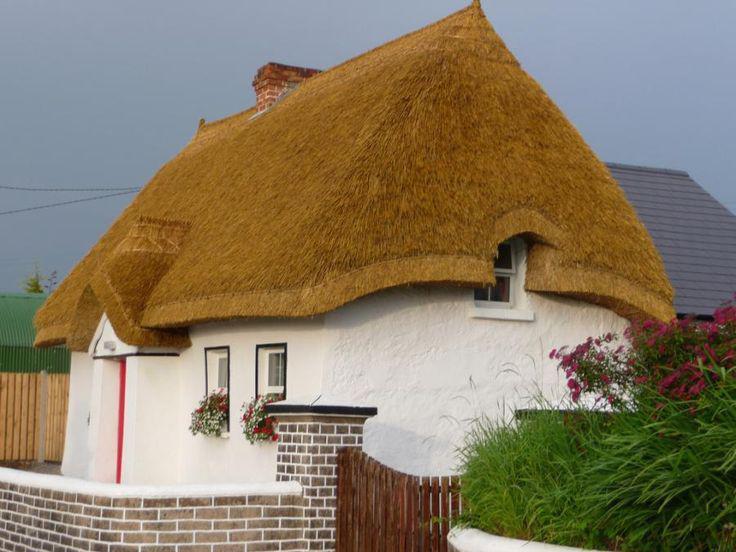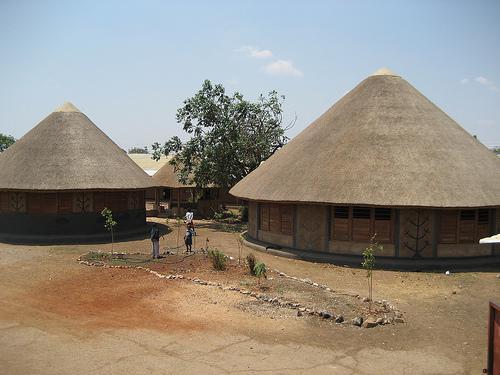The first image is the image on the left, the second image is the image on the right. Considering the images on both sides, is "A person is standing outside near a building in one of the images." valid? Answer yes or no. Yes. The first image is the image on the left, the second image is the image on the right. For the images displayed, is the sentence "The right image shows several low round buildings with cone-shaped roofs in an area with brown dirt instead of grass." factually correct? Answer yes or no. Yes. 